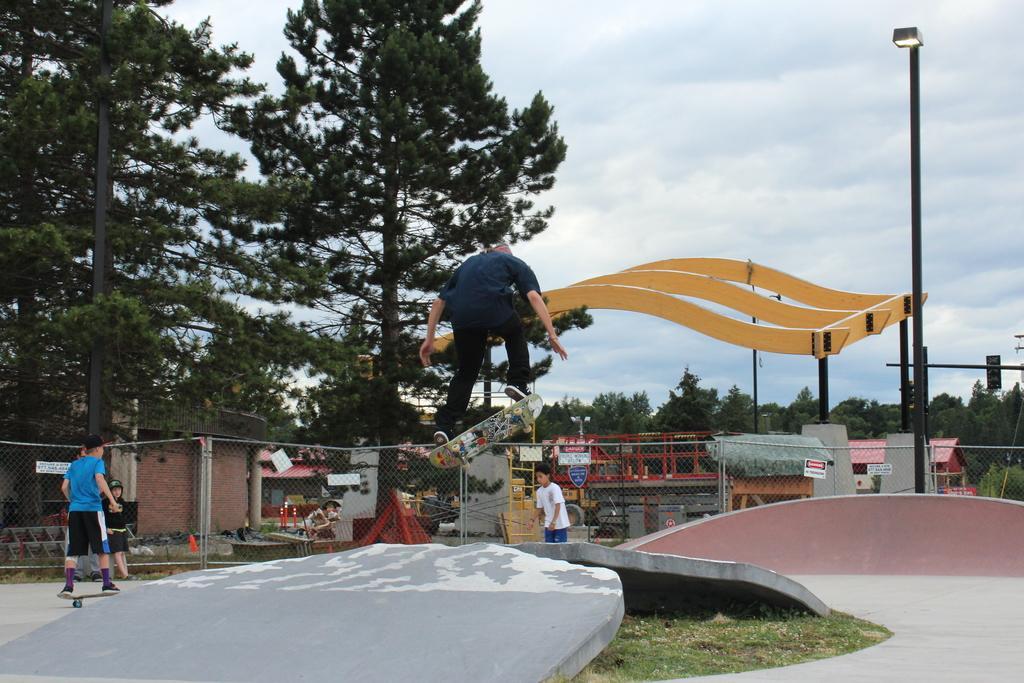Could you give a brief overview of what you see in this image? In this image there are a few people skating on the ground. In the center there is a man jumping. There is a skateboard below his feet. In front of them there is a net. In the background there are trees, houses and street light poles. At the top there is the sky. 